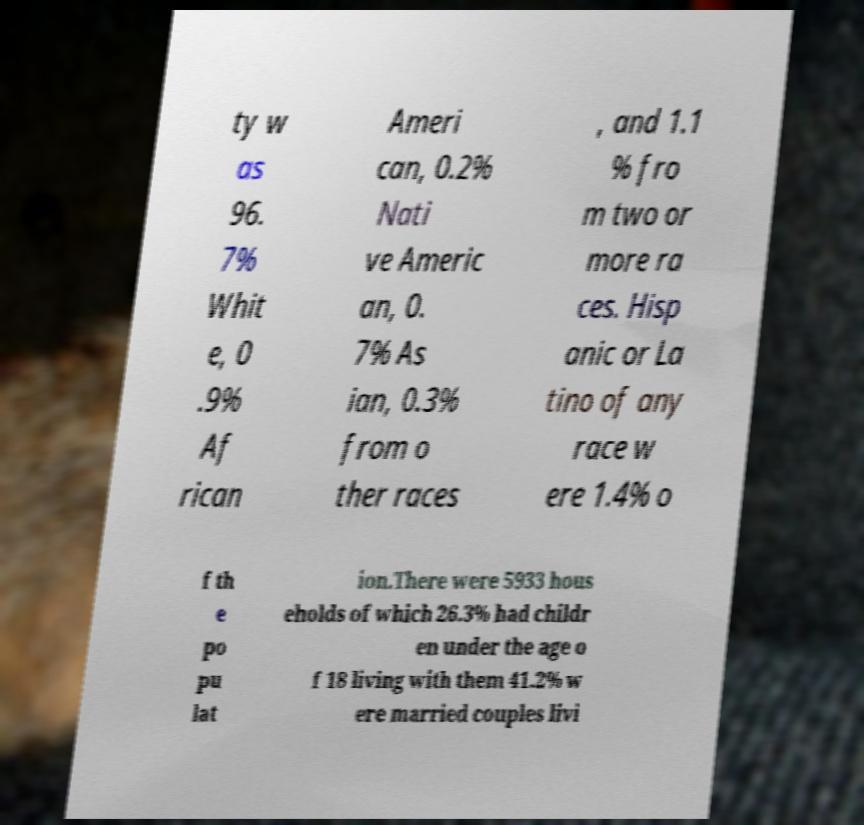For documentation purposes, I need the text within this image transcribed. Could you provide that? ty w as 96. 7% Whit e, 0 .9% Af rican Ameri can, 0.2% Nati ve Americ an, 0. 7% As ian, 0.3% from o ther races , and 1.1 % fro m two or more ra ces. Hisp anic or La tino of any race w ere 1.4% o f th e po pu lat ion.There were 5933 hous eholds of which 26.3% had childr en under the age o f 18 living with them 41.2% w ere married couples livi 